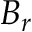Convert formula to latex. <formula><loc_0><loc_0><loc_500><loc_500>B _ { r }</formula> 